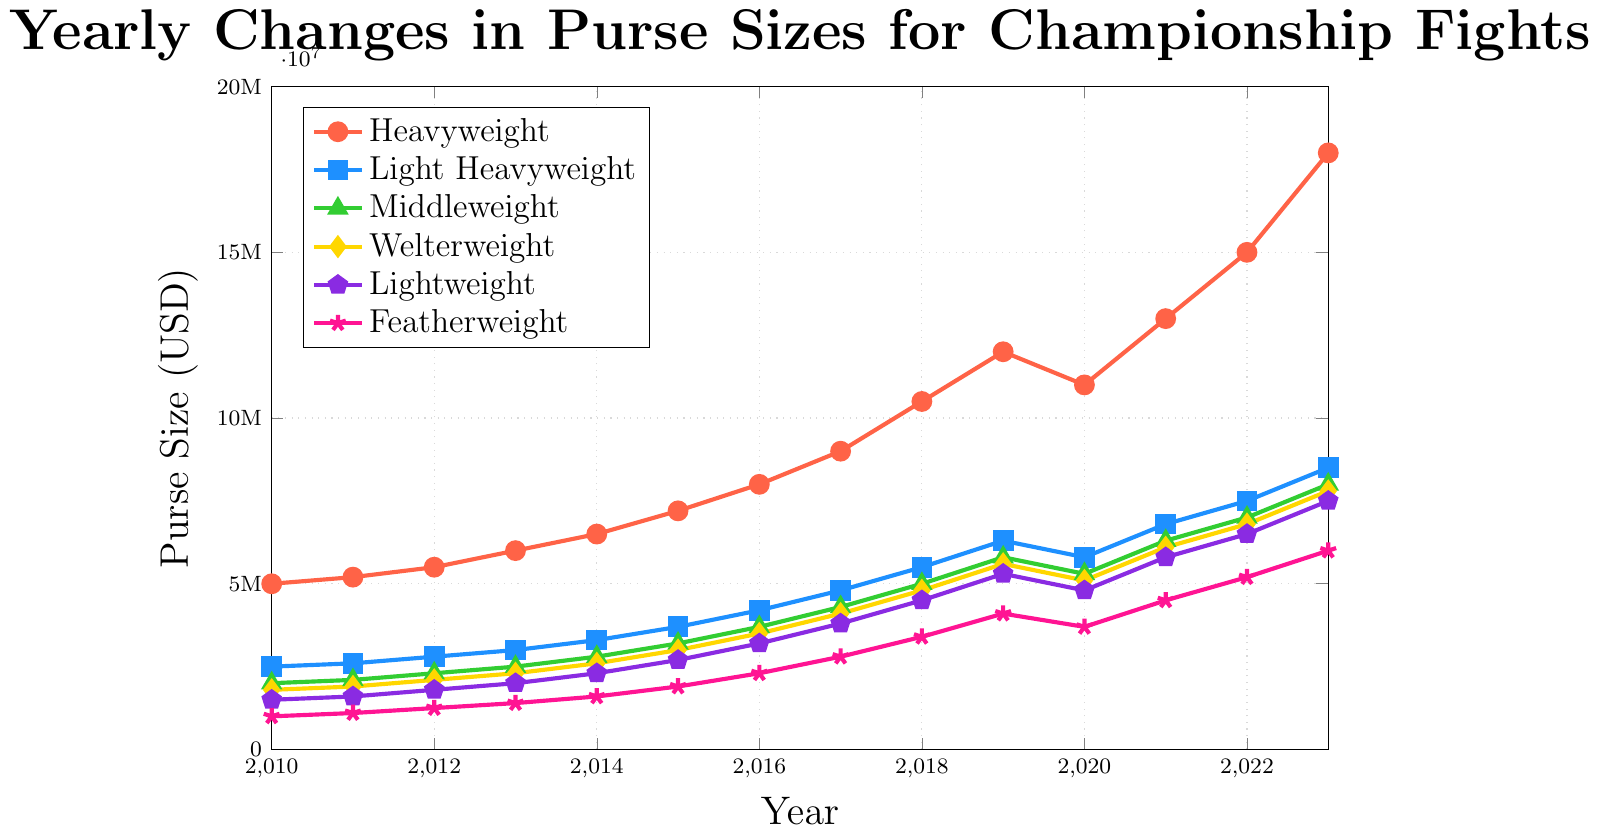Which weight class had the highest purse size in 2023? By looking at the figure, we see the highest plotted mark in 2023, which belongs to the Heavyweight class.
Answer: Heavyweight Which weight class shows the largest increase in purse size from 2010 to 2023? By tracing the lines for each weight class from 2010 to 2023, we see that the Heavyweight class had the largest increase, from $5M to $18M.
Answer: Heavyweight Compare the purse sizes of Middleweight and Welterweight classes in 2020. Which one was higher? By examining the plotted points for 2020, Middleweight had $5.3M, while Welterweight had $5.1M. Middleweight was higher.
Answer: Middleweight What is the average purse size of the Lightweight class from 2010 to 2023? Sum the purse sizes from 2010 to 2023 for Lightweight: $1.5M + $1.6M + $1.8M + $2M + $2.3M + $2.7M + $3.2M + $3.8M + $4.5M + $5.3M + $4.8M + $5.8M + $6.5M + $7.5M. The total is $53.3M. Divide by 14 years.
Answer: $3.81M How does the increase in purse size from 2010 to 2023 compare between the Featherweight and Light Heavyweight classes? Featherweight increased from $1M to $6M, an increase of $5M. Light Heavyweight increased from $2.5M to $8.5M, an increase of $6M. Light Heavyweight had a larger increase by $1M.
Answer: Light Heavyweight What trend is observed in the purse sizes of the Heavyweight class from 2010 to 2023? The Heavyweight class shows a general increasing trend over the years, with a dip in 2020 before continuing to rise.
Answer: Increasing How does the purse size of the Welterweight class change between 2015 and 2020? The purse size increases from $3M in 2015 to $5.6M in 2019 and then drops to $5.1M in 2020.
Answer: Increase then slight decrease Which weight class had the smallest purse size in 2012? By identifying the lowest points for 2012, the Featherweight class had the smallest purse size at $1.25M.
Answer: Featherweight What is the difference in purse sizes between the Light Heavyweight and Featherweight classes in 2023? In 2023, the Light Heavyweight purse size is $8.5M, and the Featherweight is $6M, giving a difference of $2.5M.
Answer: $2.5M 